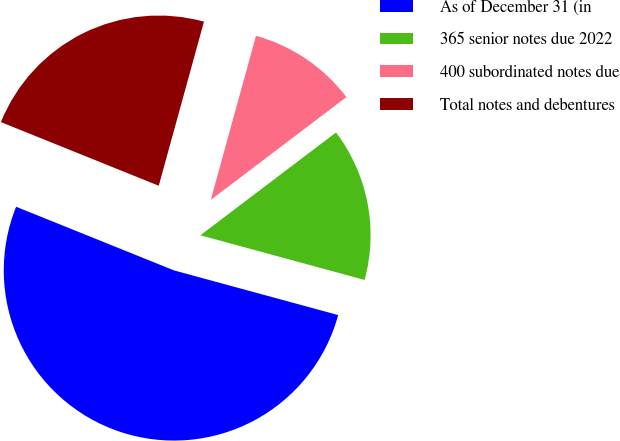Convert chart to OTSL. <chart><loc_0><loc_0><loc_500><loc_500><pie_chart><fcel>As of December 31 (in<fcel>365 senior notes due 2022<fcel>400 subordinated notes due<fcel>Total notes and debentures<nl><fcel>51.87%<fcel>14.55%<fcel>10.4%<fcel>23.18%<nl></chart> 